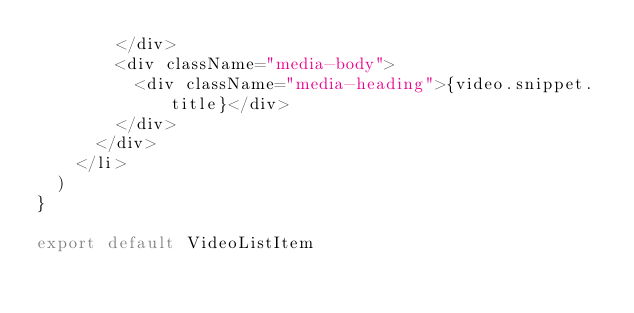<code> <loc_0><loc_0><loc_500><loc_500><_JavaScript_>        </div>
        <div className="media-body">
          <div className="media-heading">{video.snippet.title}</div>
        </div>
      </div>
    </li>
  )
}

export default VideoListItem
</code> 